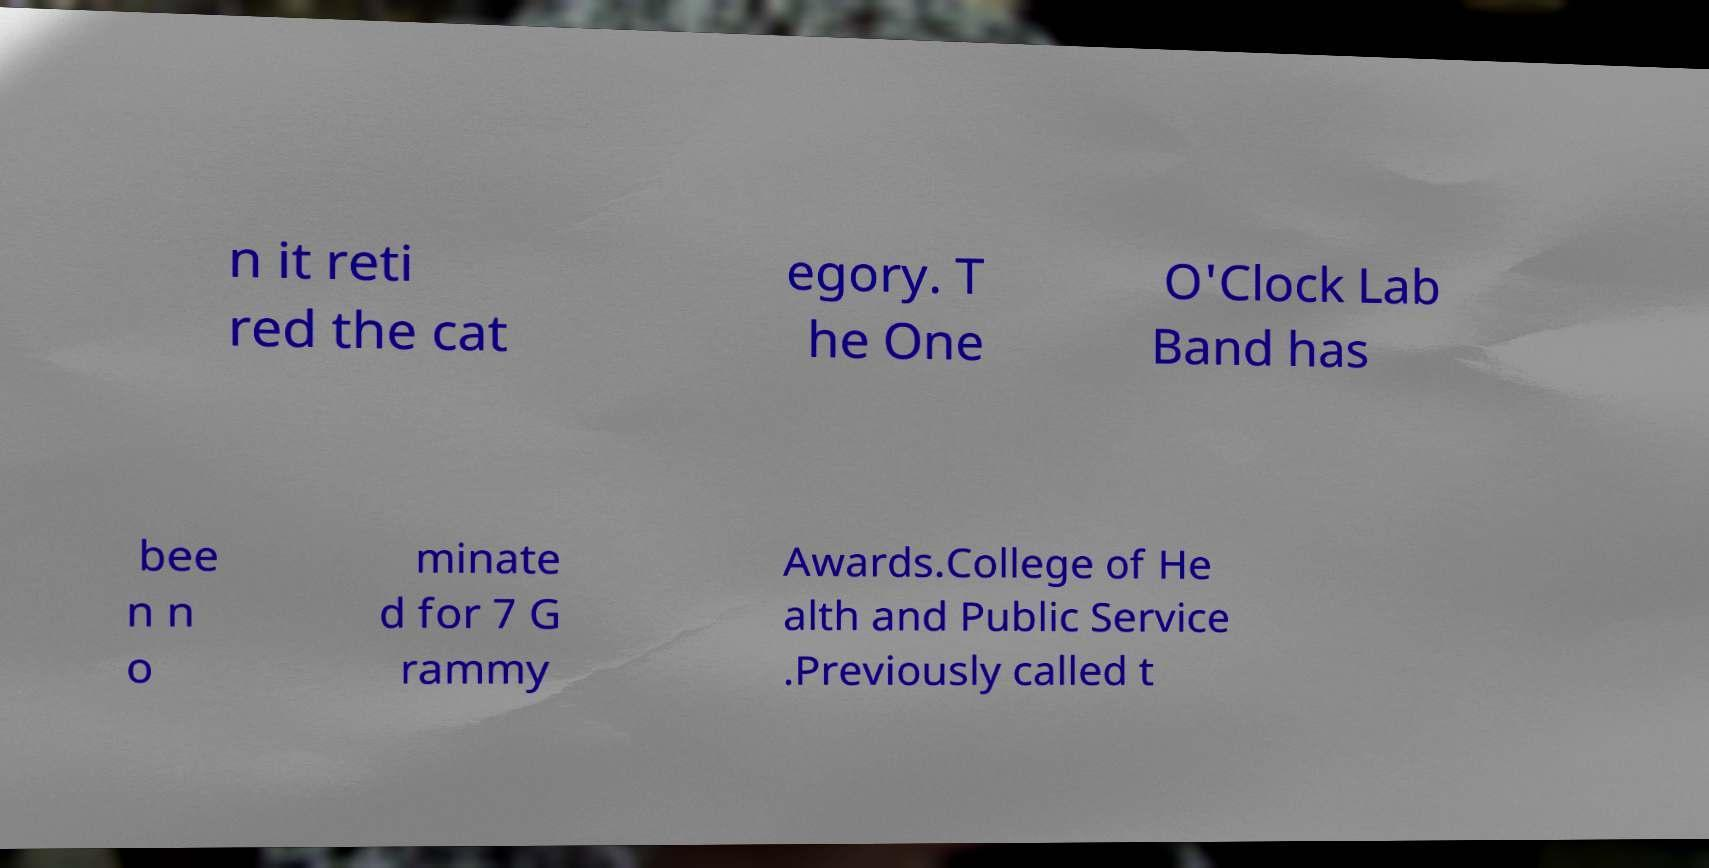Could you extract and type out the text from this image? n it reti red the cat egory. T he One O'Clock Lab Band has bee n n o minate d for 7 G rammy Awards.College of He alth and Public Service .Previously called t 